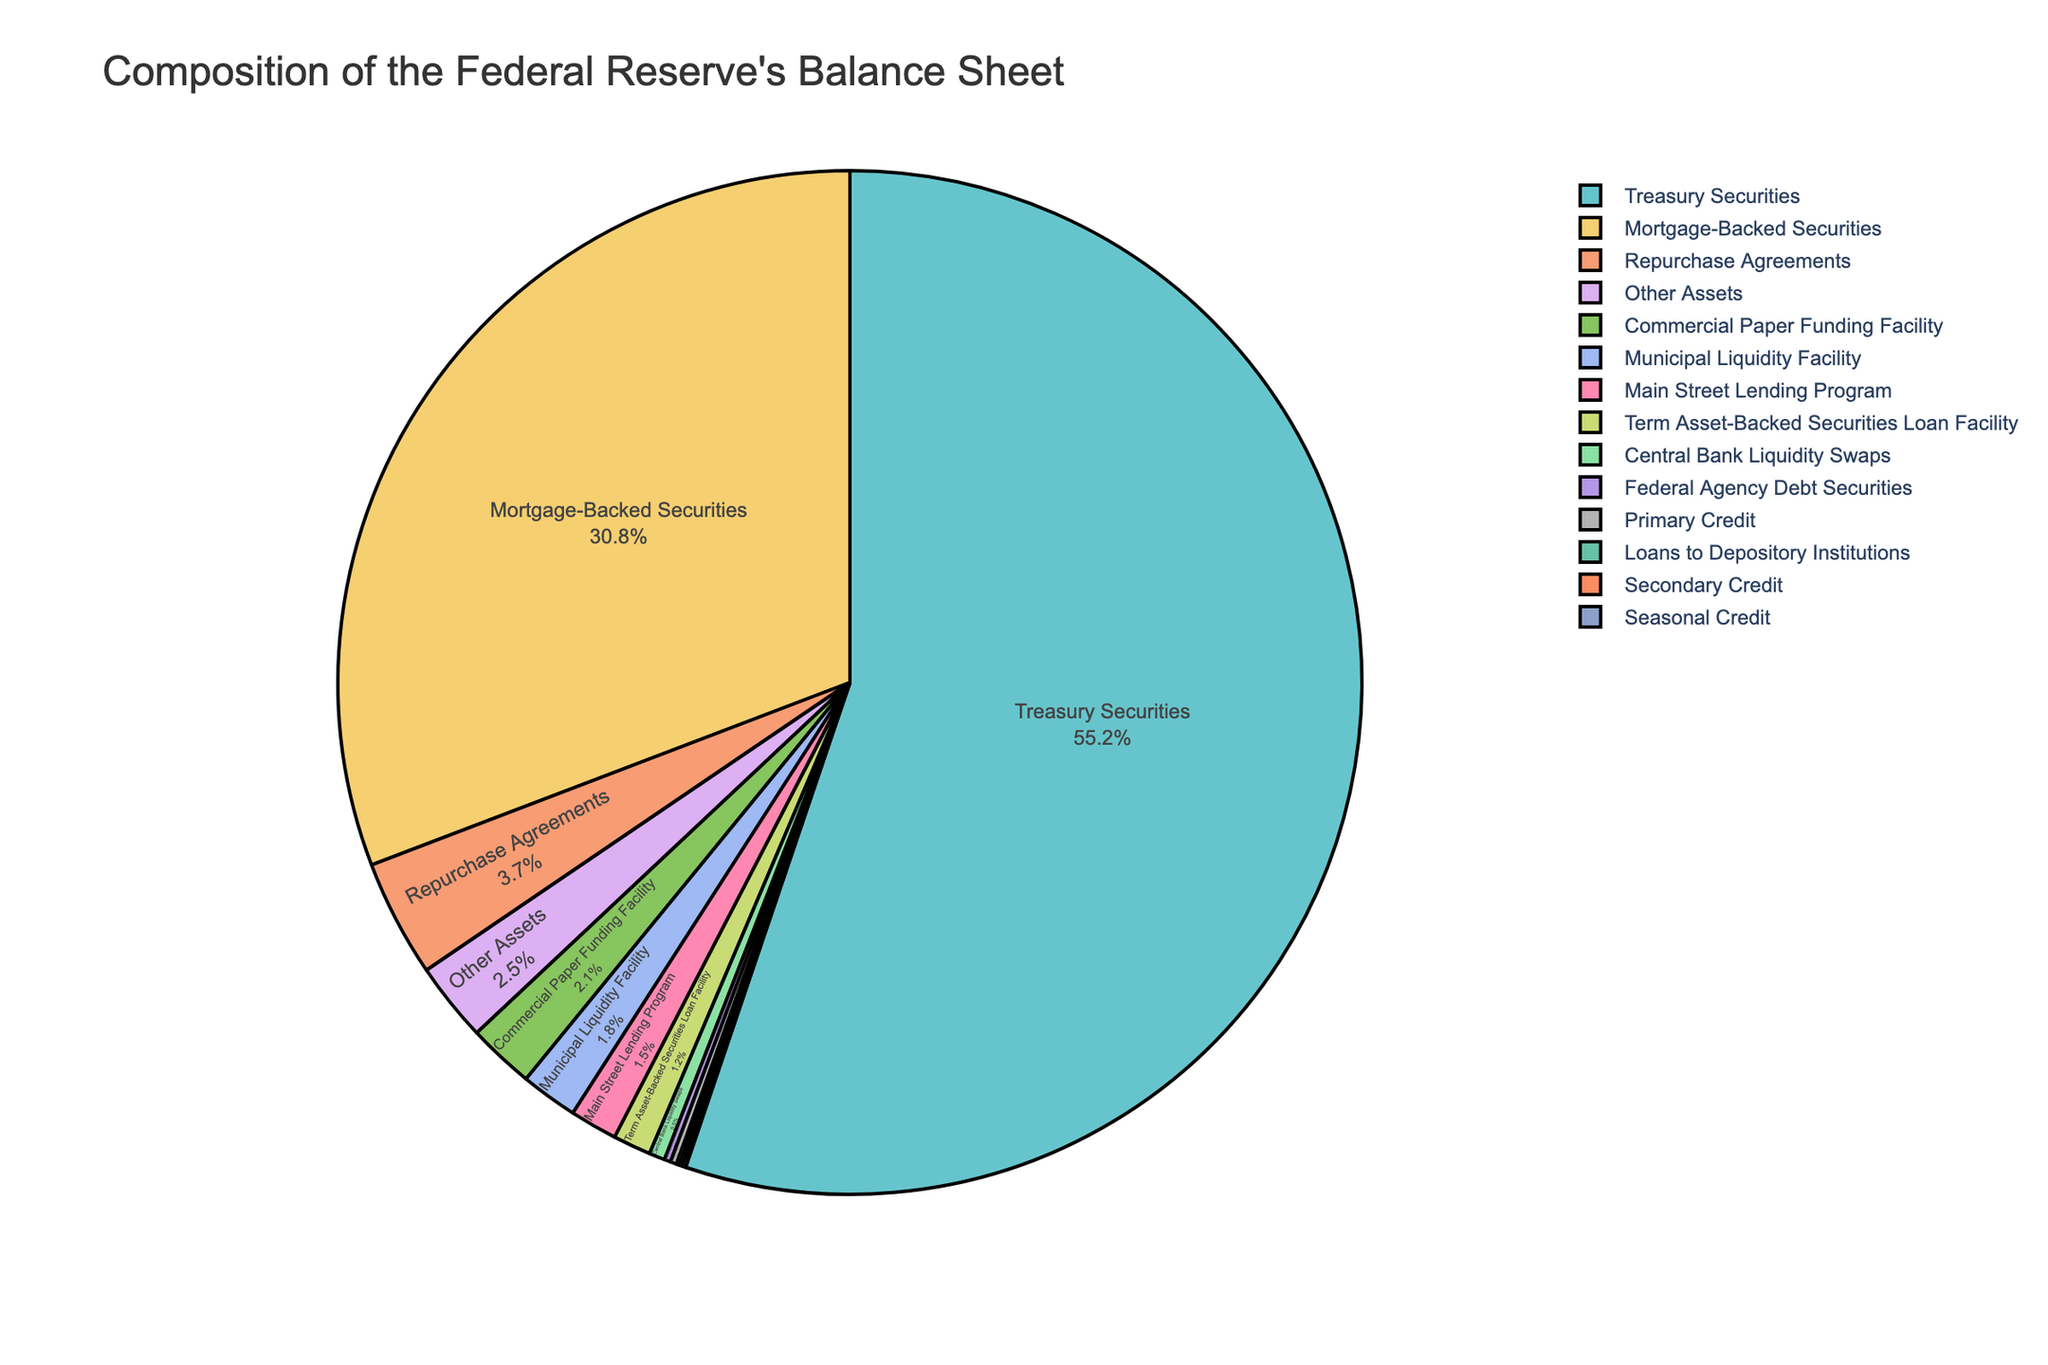Which asset type has the largest percentage on the Federal Reserve's balance sheet? Look at the segment in the pie chart that covers the largest area. The largest percentage belongs to Treasury Securities.
Answer: Treasury Securities Which asset type has the smallest percentage on the Federal Reserve's balance sheet? Identify the smallest segment on the pie chart. Federal Agency Debt Securities, Loans to Depository Institutions, Secondary Credit, and Seasonal Credit each have very small percentages, but Federal Agency Debt Securities is the smallest category.
Answer: Federal Agency Debt Securities What is the combined percentage of Treasury Securities and Mortgage-Backed Securities? Add the percentages of Treasury Securities (55.2%) and Mortgage-Backed Securities (30.8%). 55.2 + 30.8 = 86%
Answer: 86% Compare the percentage of Repurchase Agreements to that of the Main Street Lending Program. Which one is larger? Repurchase Agreements and Main Street Lending Program are identified on the pie chart, with Repurchase Agreements at 3.7% and Main Street Lending Program at 1.5%. 3.7% > 1.5%
Answer: Repurchase Agreements How does the percentage of Term Asset-Backed Securities Loan Facility compare to that of the Commercial Paper Funding Facility? Locate both percentages on the pie chart: Term Asset-Backed Securities Loan Facility (1.2%) and Commercial Paper Funding Facility (2.1%). Compare the two values to see which one is larger.
Answer: Commercial Paper Funding Facility What is the total percentage of the asset types with individual percentages less than 1%? Add the percentages of Central Bank Liquidity Swaps (0.5%), Federal Agency Debt Securities (0.2%), Loans to Depository Institutions (0.1%), Primary Credit (0.2%), and Secondary Credit (0.1%). 0.5 + 0.2 + 0.1 + 0.2 + 0.1 = 1.1%
Answer: 1.1% How does the percentage of Other Assets compare to that of the Municipal Liquidity Facility? Observe the pie chart to find the percentages of Other Assets (2.5%) and Municipal Liquidity Facility (1.8%). Compare these values.
Answer: Other Assets What is the difference in percentage points between Mortgage-Backed Securities and Commercial Paper Funding Facility? Subtract the percentage of Commercial Paper Funding Facility (2.1%) from Mortgage-Backed Securities (30.8%). 30.8 - 2.1 = 28.7
Answer: 28.7 Which asset types collectively make up over 90% of the Federal Reserve's balance sheet? Identify the largest segments until the sum exceeds 90%. Treasury Securities, Mortgage-Backed Securities, and Repurchase Agreements together make up 55.2% + 30.8% + 3.7% = 89.7%; adding Term Asset-Backed Securities Loan Facility (1.2%) raises the total to 90.9%.
Answer: Treasury Securities, Mortgage-Backed Securities, Repurchase Agreements, and Term Asset-Backed Securities Loan Facility 